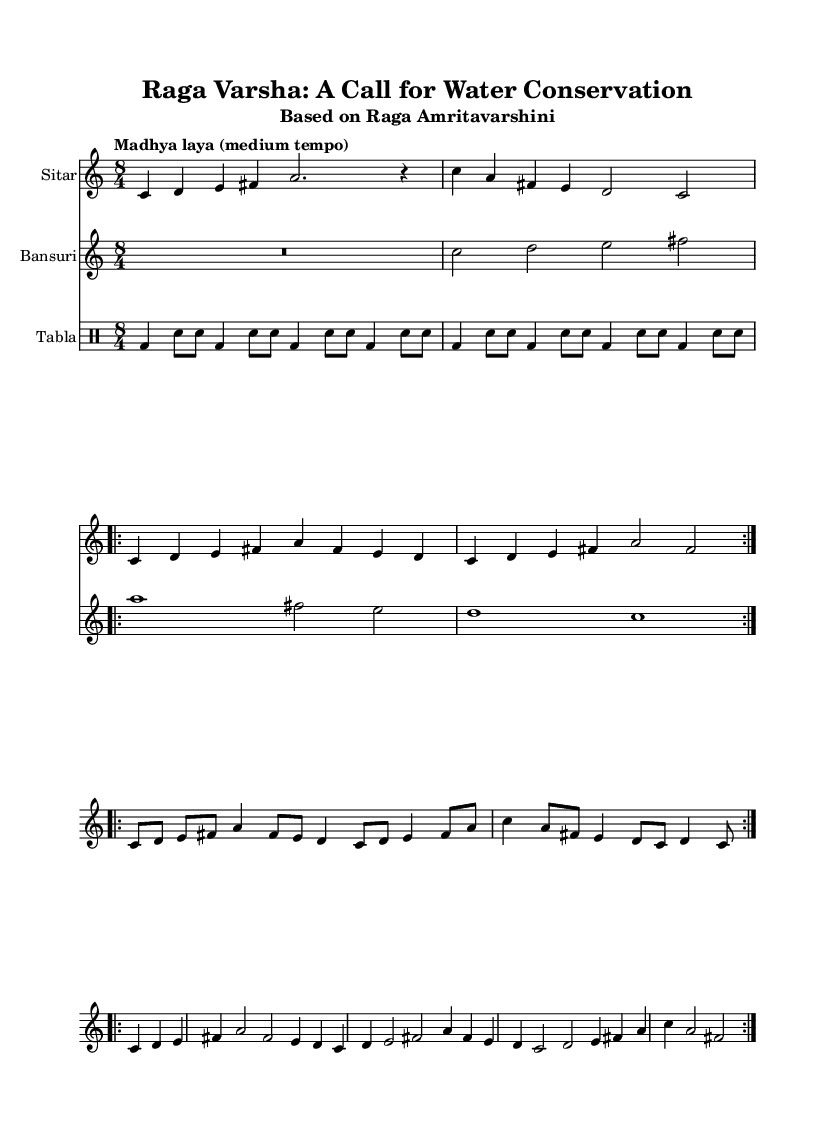What is the key signature of this music? The key signature is C major, which is indicated at the beginning of the score and has no sharps or flats.
Answer: C major What is the time signature of the piece? The time signature is indicated as 8/4 at the start of the score, indicating each measure contains eight beats.
Answer: 8/4 What is the tempo marking for this composition? The tempo marking is specified as "Madhya laya (medium tempo)," which guides the performer on the speed at which to play the piece.
Answer: Madhya laya (medium tempo) How many bars are in the Alap section for Sitar? In the Alap section for Sitar, there are a total of four bars, as counted from the notation provided starting from the first line.
Answer: 4 What instrument primarily plays the melody in this piece? The primary instrument playing the melody is the Sitar, as indicated by its dedicated staff and notation.
Answer: Sitar How many times is the Jor section repeated for Sitar? The Jor section is indicated to be repeated two times, as noted with the 'volta' marking in the score.
Answer: 2 